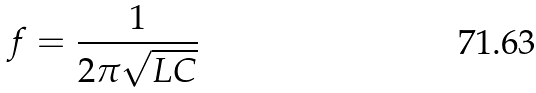<formula> <loc_0><loc_0><loc_500><loc_500>f = \frac { 1 } { 2 \pi \sqrt { L C } }</formula> 